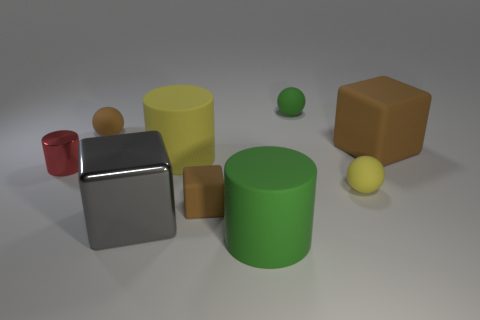Subtract all green cylinders. How many cylinders are left? 2 Subtract all brown blocks. How many blocks are left? 1 Subtract all cylinders. How many objects are left? 6 Subtract 3 balls. How many balls are left? 0 Subtract all gray cubes. Subtract all tiny blue shiny blocks. How many objects are left? 8 Add 4 green rubber spheres. How many green rubber spheres are left? 5 Add 7 cyan cylinders. How many cyan cylinders exist? 7 Subtract 0 cyan cylinders. How many objects are left? 9 Subtract all green cylinders. Subtract all red cubes. How many cylinders are left? 2 Subtract all green cylinders. How many purple blocks are left? 0 